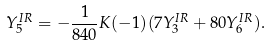<formula> <loc_0><loc_0><loc_500><loc_500>Y _ { 5 } ^ { I R } = - \frac { 1 } { 8 4 0 } K ( - 1 ) ( 7 Y _ { 3 } ^ { I R } + 8 0 Y _ { 6 } ^ { I R } ) .</formula> 